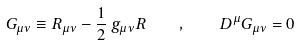<formula> <loc_0><loc_0><loc_500><loc_500>G _ { \mu \nu } \equiv R _ { \mu \nu } - \frac { 1 } { 2 } \, g _ { \mu \nu } R \quad , \quad D ^ { \mu } G _ { \mu \nu } = 0</formula> 